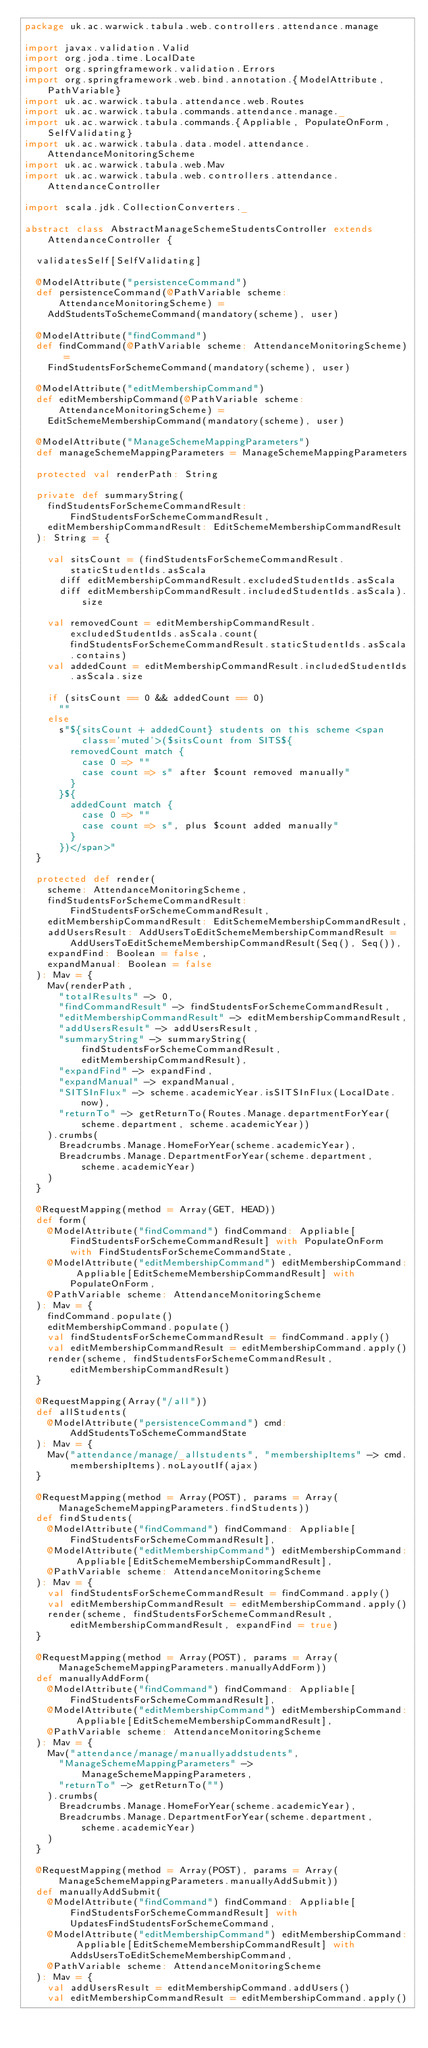<code> <loc_0><loc_0><loc_500><loc_500><_Scala_>package uk.ac.warwick.tabula.web.controllers.attendance.manage

import javax.validation.Valid
import org.joda.time.LocalDate
import org.springframework.validation.Errors
import org.springframework.web.bind.annotation.{ModelAttribute, PathVariable}
import uk.ac.warwick.tabula.attendance.web.Routes
import uk.ac.warwick.tabula.commands.attendance.manage._
import uk.ac.warwick.tabula.commands.{Appliable, PopulateOnForm, SelfValidating}
import uk.ac.warwick.tabula.data.model.attendance.AttendanceMonitoringScheme
import uk.ac.warwick.tabula.web.Mav
import uk.ac.warwick.tabula.web.controllers.attendance.AttendanceController

import scala.jdk.CollectionConverters._

abstract class AbstractManageSchemeStudentsController extends AttendanceController {

  validatesSelf[SelfValidating]

  @ModelAttribute("persistenceCommand")
  def persistenceCommand(@PathVariable scheme: AttendanceMonitoringScheme) =
    AddStudentsToSchemeCommand(mandatory(scheme), user)

  @ModelAttribute("findCommand")
  def findCommand(@PathVariable scheme: AttendanceMonitoringScheme) =
    FindStudentsForSchemeCommand(mandatory(scheme), user)

  @ModelAttribute("editMembershipCommand")
  def editMembershipCommand(@PathVariable scheme: AttendanceMonitoringScheme) =
    EditSchemeMembershipCommand(mandatory(scheme), user)

  @ModelAttribute("ManageSchemeMappingParameters")
  def manageSchemeMappingParameters = ManageSchemeMappingParameters

  protected val renderPath: String

  private def summaryString(
    findStudentsForSchemeCommandResult: FindStudentsForSchemeCommandResult,
    editMembershipCommandResult: EditSchemeMembershipCommandResult
  ): String = {

    val sitsCount = (findStudentsForSchemeCommandResult.staticStudentIds.asScala
      diff editMembershipCommandResult.excludedStudentIds.asScala
      diff editMembershipCommandResult.includedStudentIds.asScala).size

    val removedCount = editMembershipCommandResult.excludedStudentIds.asScala.count(findStudentsForSchemeCommandResult.staticStudentIds.asScala.contains)
    val addedCount = editMembershipCommandResult.includedStudentIds.asScala.size

    if (sitsCount == 0 && addedCount == 0)
      ""
    else
      s"${sitsCount + addedCount} students on this scheme <span class='muted'>($sitsCount from SITS${
        removedCount match {
          case 0 => ""
          case count => s" after $count removed manually"
        }
      }${
        addedCount match {
          case 0 => ""
          case count => s", plus $count added manually"
        }
      })</span>"
  }

  protected def render(
    scheme: AttendanceMonitoringScheme,
    findStudentsForSchemeCommandResult: FindStudentsForSchemeCommandResult,
    editMembershipCommandResult: EditSchemeMembershipCommandResult,
    addUsersResult: AddUsersToEditSchemeMembershipCommandResult = AddUsersToEditSchemeMembershipCommandResult(Seq(), Seq()),
    expandFind: Boolean = false,
    expandManual: Boolean = false
  ): Mav = {
    Mav(renderPath,
      "totalResults" -> 0,
      "findCommandResult" -> findStudentsForSchemeCommandResult,
      "editMembershipCommandResult" -> editMembershipCommandResult,
      "addUsersResult" -> addUsersResult,
      "summaryString" -> summaryString(findStudentsForSchemeCommandResult, editMembershipCommandResult),
      "expandFind" -> expandFind,
      "expandManual" -> expandManual,
      "SITSInFlux" -> scheme.academicYear.isSITSInFlux(LocalDate.now),
      "returnTo" -> getReturnTo(Routes.Manage.departmentForYear(scheme.department, scheme.academicYear))
    ).crumbs(
      Breadcrumbs.Manage.HomeForYear(scheme.academicYear),
      Breadcrumbs.Manage.DepartmentForYear(scheme.department, scheme.academicYear)
    )
  }

  @RequestMapping(method = Array(GET, HEAD))
  def form(
    @ModelAttribute("findCommand") findCommand: Appliable[FindStudentsForSchemeCommandResult] with PopulateOnForm with FindStudentsForSchemeCommandState,
    @ModelAttribute("editMembershipCommand") editMembershipCommand: Appliable[EditSchemeMembershipCommandResult] with PopulateOnForm,
    @PathVariable scheme: AttendanceMonitoringScheme
  ): Mav = {
    findCommand.populate()
    editMembershipCommand.populate()
    val findStudentsForSchemeCommandResult = findCommand.apply()
    val editMembershipCommandResult = editMembershipCommand.apply()
    render(scheme, findStudentsForSchemeCommandResult, editMembershipCommandResult)
  }

  @RequestMapping(Array("/all"))
  def allStudents(
    @ModelAttribute("persistenceCommand") cmd: AddStudentsToSchemeCommandState
  ): Mav = {
    Mav("attendance/manage/_allstudents", "membershipItems" -> cmd.membershipItems).noLayoutIf(ajax)
  }

  @RequestMapping(method = Array(POST), params = Array(ManageSchemeMappingParameters.findStudents))
  def findStudents(
    @ModelAttribute("findCommand") findCommand: Appliable[FindStudentsForSchemeCommandResult],
    @ModelAttribute("editMembershipCommand") editMembershipCommand: Appliable[EditSchemeMembershipCommandResult],
    @PathVariable scheme: AttendanceMonitoringScheme
  ): Mav = {
    val findStudentsForSchemeCommandResult = findCommand.apply()
    val editMembershipCommandResult = editMembershipCommand.apply()
    render(scheme, findStudentsForSchemeCommandResult, editMembershipCommandResult, expandFind = true)
  }

  @RequestMapping(method = Array(POST), params = Array(ManageSchemeMappingParameters.manuallyAddForm))
  def manuallyAddForm(
    @ModelAttribute("findCommand") findCommand: Appliable[FindStudentsForSchemeCommandResult],
    @ModelAttribute("editMembershipCommand") editMembershipCommand: Appliable[EditSchemeMembershipCommandResult],
    @PathVariable scheme: AttendanceMonitoringScheme
  ): Mav = {
    Mav("attendance/manage/manuallyaddstudents",
      "ManageSchemeMappingParameters" -> ManageSchemeMappingParameters,
      "returnTo" -> getReturnTo("")
    ).crumbs(
      Breadcrumbs.Manage.HomeForYear(scheme.academicYear),
      Breadcrumbs.Manage.DepartmentForYear(scheme.department, scheme.academicYear)
    )
  }

  @RequestMapping(method = Array(POST), params = Array(ManageSchemeMappingParameters.manuallyAddSubmit))
  def manuallyAddSubmit(
    @ModelAttribute("findCommand") findCommand: Appliable[FindStudentsForSchemeCommandResult] with UpdatesFindStudentsForSchemeCommand,
    @ModelAttribute("editMembershipCommand") editMembershipCommand: Appliable[EditSchemeMembershipCommandResult] with AddsUsersToEditSchemeMembershipCommand,
    @PathVariable scheme: AttendanceMonitoringScheme
  ): Mav = {
    val addUsersResult = editMembershipCommand.addUsers()
    val editMembershipCommandResult = editMembershipCommand.apply()</code> 